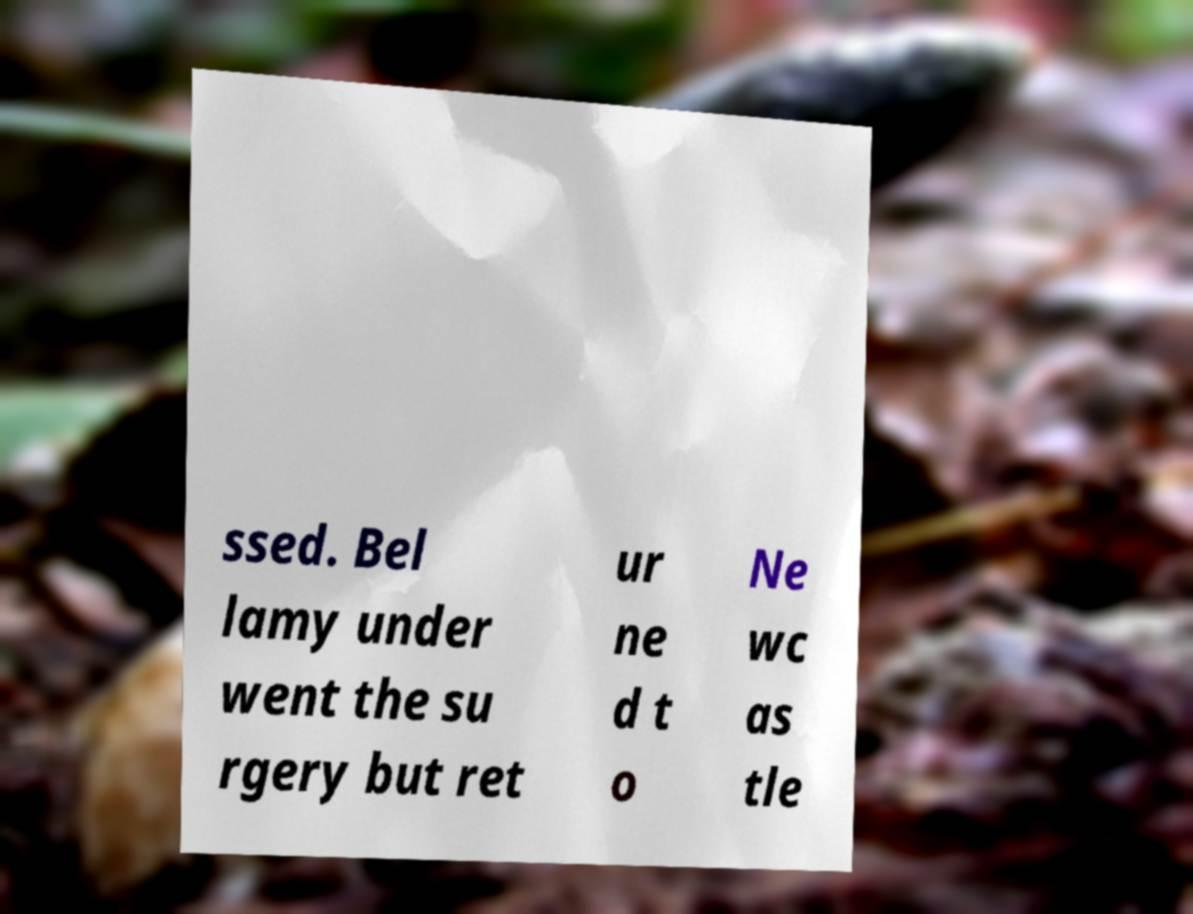There's text embedded in this image that I need extracted. Can you transcribe it verbatim? ssed. Bel lamy under went the su rgery but ret ur ne d t o Ne wc as tle 